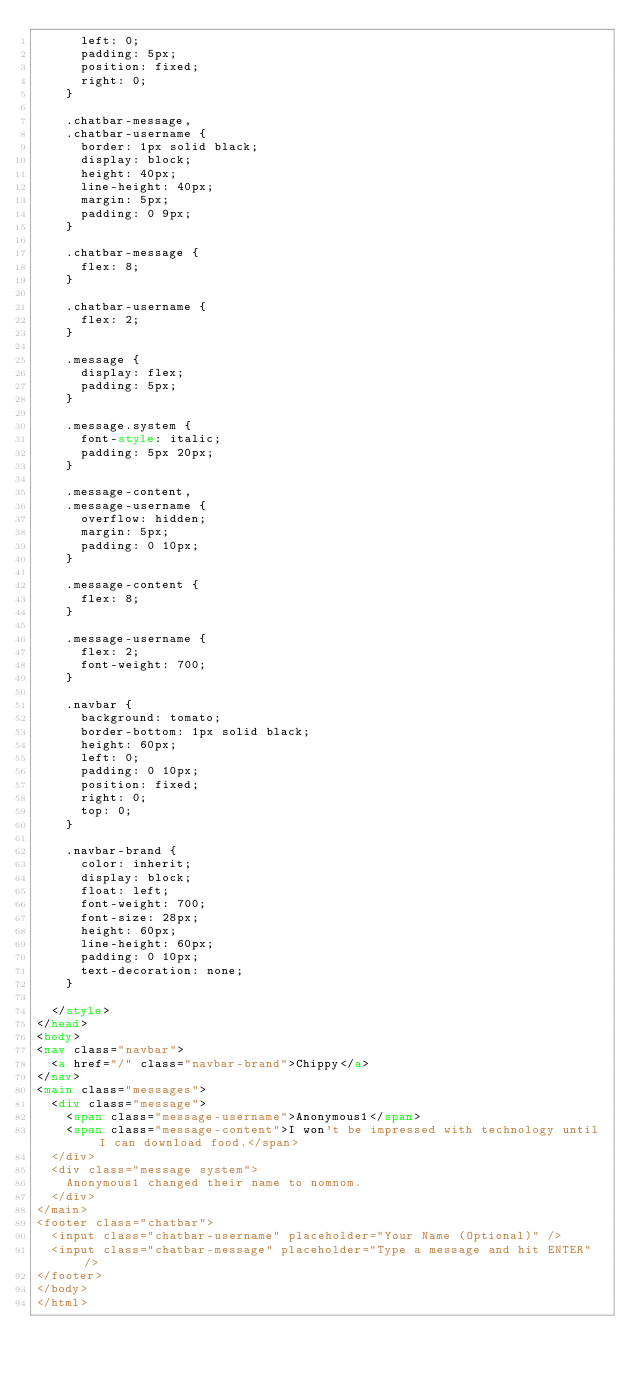<code> <loc_0><loc_0><loc_500><loc_500><_HTML_>      left: 0;
      padding: 5px;
      position: fixed;
      right: 0;
    }

    .chatbar-message,
    .chatbar-username {
      border: 1px solid black;
      display: block;
      height: 40px;
      line-height: 40px;
      margin: 5px;
      padding: 0 9px;
    }

    .chatbar-message {
      flex: 8;
    }

    .chatbar-username {
      flex: 2;
    }

    .message {
      display: flex;
      padding: 5px;
    }

    .message.system {
      font-style: italic;
      padding: 5px 20px;
    }

    .message-content,
    .message-username {
      overflow: hidden;
      margin: 5px;
      padding: 0 10px;
    }

    .message-content {
      flex: 8;
    }

    .message-username {
      flex: 2;
      font-weight: 700;
    }

    .navbar {
      background: tomato;
      border-bottom: 1px solid black;
      height: 60px;
      left: 0;
      padding: 0 10px;
      position: fixed;
      right: 0;
      top: 0;
    }

    .navbar-brand {
      color: inherit;
      display: block;
      float: left;
      font-weight: 700;
      font-size: 28px;
      height: 60px;
      line-height: 60px;
      padding: 0 10px;
      text-decoration: none;
    }

  </style>
</head>
<body>
<nav class="navbar">
  <a href="/" class="navbar-brand">Chippy</a>
</nav>
<main class="messages">
  <div class="message">
    <span class="message-username">Anonymous1</span>
    <span class="message-content">I won't be impressed with technology until I can download food.</span>
  </div>
  <div class="message system">
    Anonymous1 changed their name to nomnom.
  </div>
</main>
<footer class="chatbar">
  <input class="chatbar-username" placeholder="Your Name (Optional)" />
  <input class="chatbar-message" placeholder="Type a message and hit ENTER" />
</footer>
</body>
</html></code> 